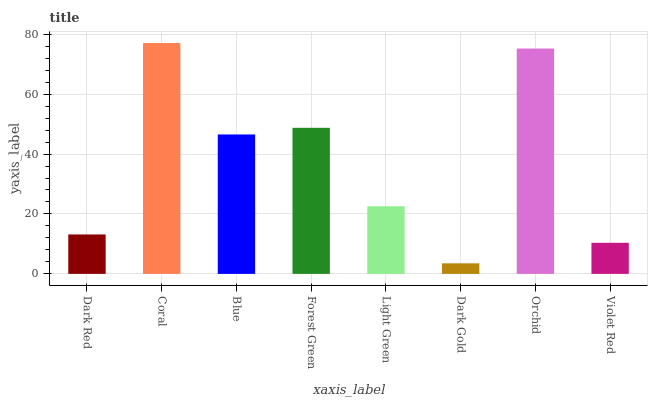Is Dark Gold the minimum?
Answer yes or no. Yes. Is Coral the maximum?
Answer yes or no. Yes. Is Blue the minimum?
Answer yes or no. No. Is Blue the maximum?
Answer yes or no. No. Is Coral greater than Blue?
Answer yes or no. Yes. Is Blue less than Coral?
Answer yes or no. Yes. Is Blue greater than Coral?
Answer yes or no. No. Is Coral less than Blue?
Answer yes or no. No. Is Blue the high median?
Answer yes or no. Yes. Is Light Green the low median?
Answer yes or no. Yes. Is Dark Gold the high median?
Answer yes or no. No. Is Coral the low median?
Answer yes or no. No. 